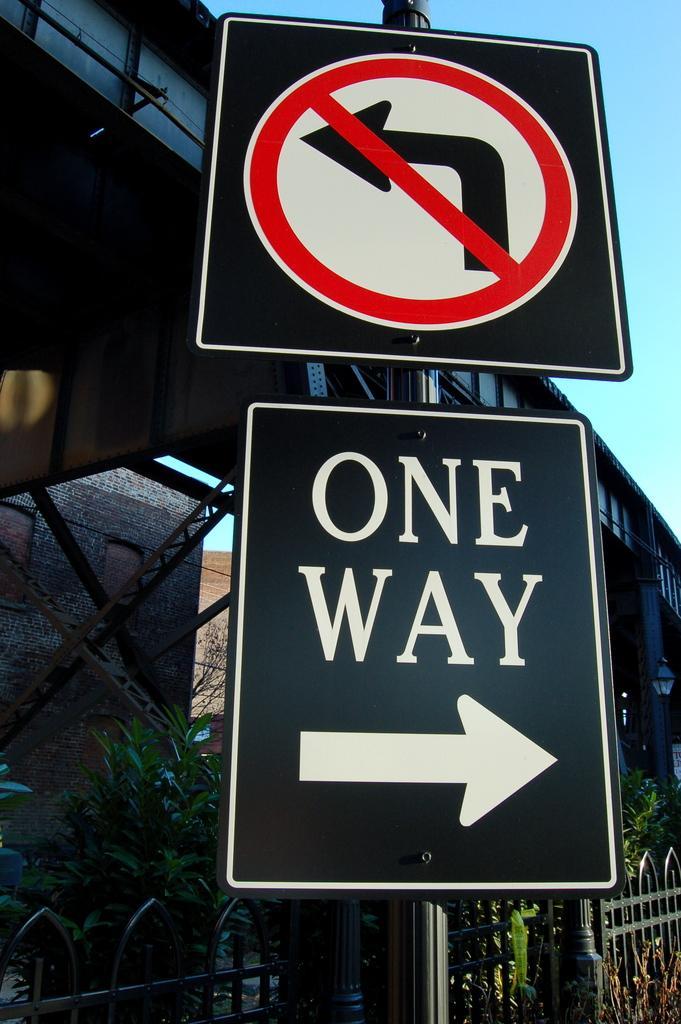Describe this image in one or two sentences. In this picture there are boards on the pole and there is text on the board. At the back there is a building and there are plants and there is a railing. At the top there is sky. 